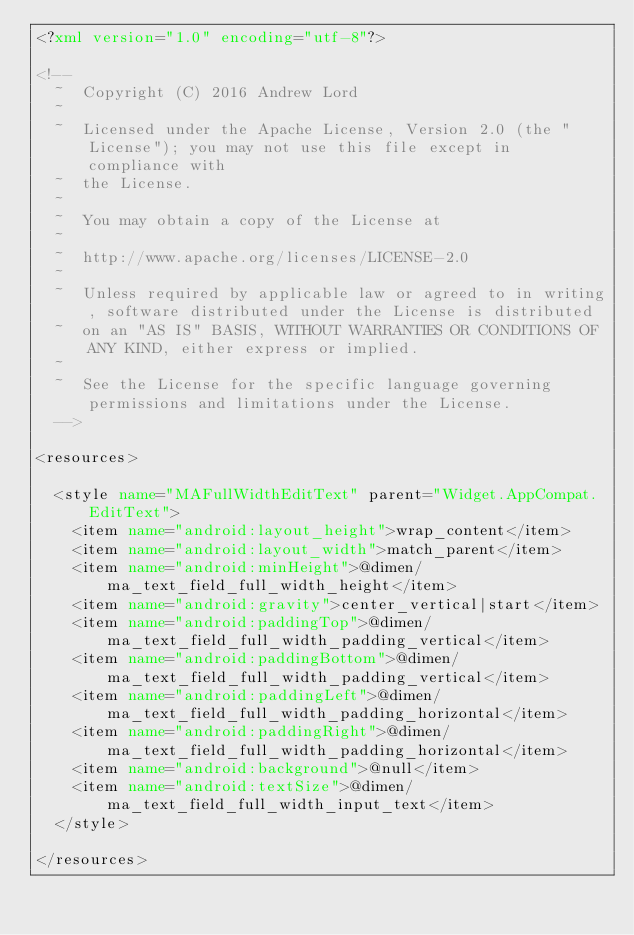<code> <loc_0><loc_0><loc_500><loc_500><_XML_><?xml version="1.0" encoding="utf-8"?>

<!--
  ~  Copyright (C) 2016 Andrew Lord
  ~
  ~  Licensed under the Apache License, Version 2.0 (the "License"); you may not use this file except in compliance with
  ~  the License.
  ~
  ~  You may obtain a copy of the License at
  ~
  ~  http://www.apache.org/licenses/LICENSE-2.0
  ~
  ~  Unless required by applicable law or agreed to in writing, software distributed under the License is distributed
  ~  on an "AS IS" BASIS, WITHOUT WARRANTIES OR CONDITIONS OF ANY KIND, either express or implied.
  ~
  ~  See the License for the specific language governing permissions and limitations under the License.
  -->

<resources>

  <style name="MAFullWidthEditText" parent="Widget.AppCompat.EditText">
    <item name="android:layout_height">wrap_content</item>
    <item name="android:layout_width">match_parent</item>
    <item name="android:minHeight">@dimen/ma_text_field_full_width_height</item>
    <item name="android:gravity">center_vertical|start</item>
    <item name="android:paddingTop">@dimen/ma_text_field_full_width_padding_vertical</item>
    <item name="android:paddingBottom">@dimen/ma_text_field_full_width_padding_vertical</item>
    <item name="android:paddingLeft">@dimen/ma_text_field_full_width_padding_horizontal</item>
    <item name="android:paddingRight">@dimen/ma_text_field_full_width_padding_horizontal</item>
    <item name="android:background">@null</item>
    <item name="android:textSize">@dimen/ma_text_field_full_width_input_text</item>
  </style>

</resources></code> 